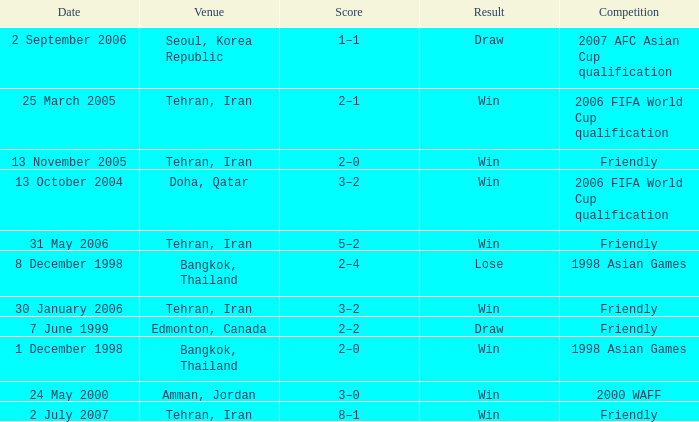What was the competition on 7 June 1999? Friendly. 